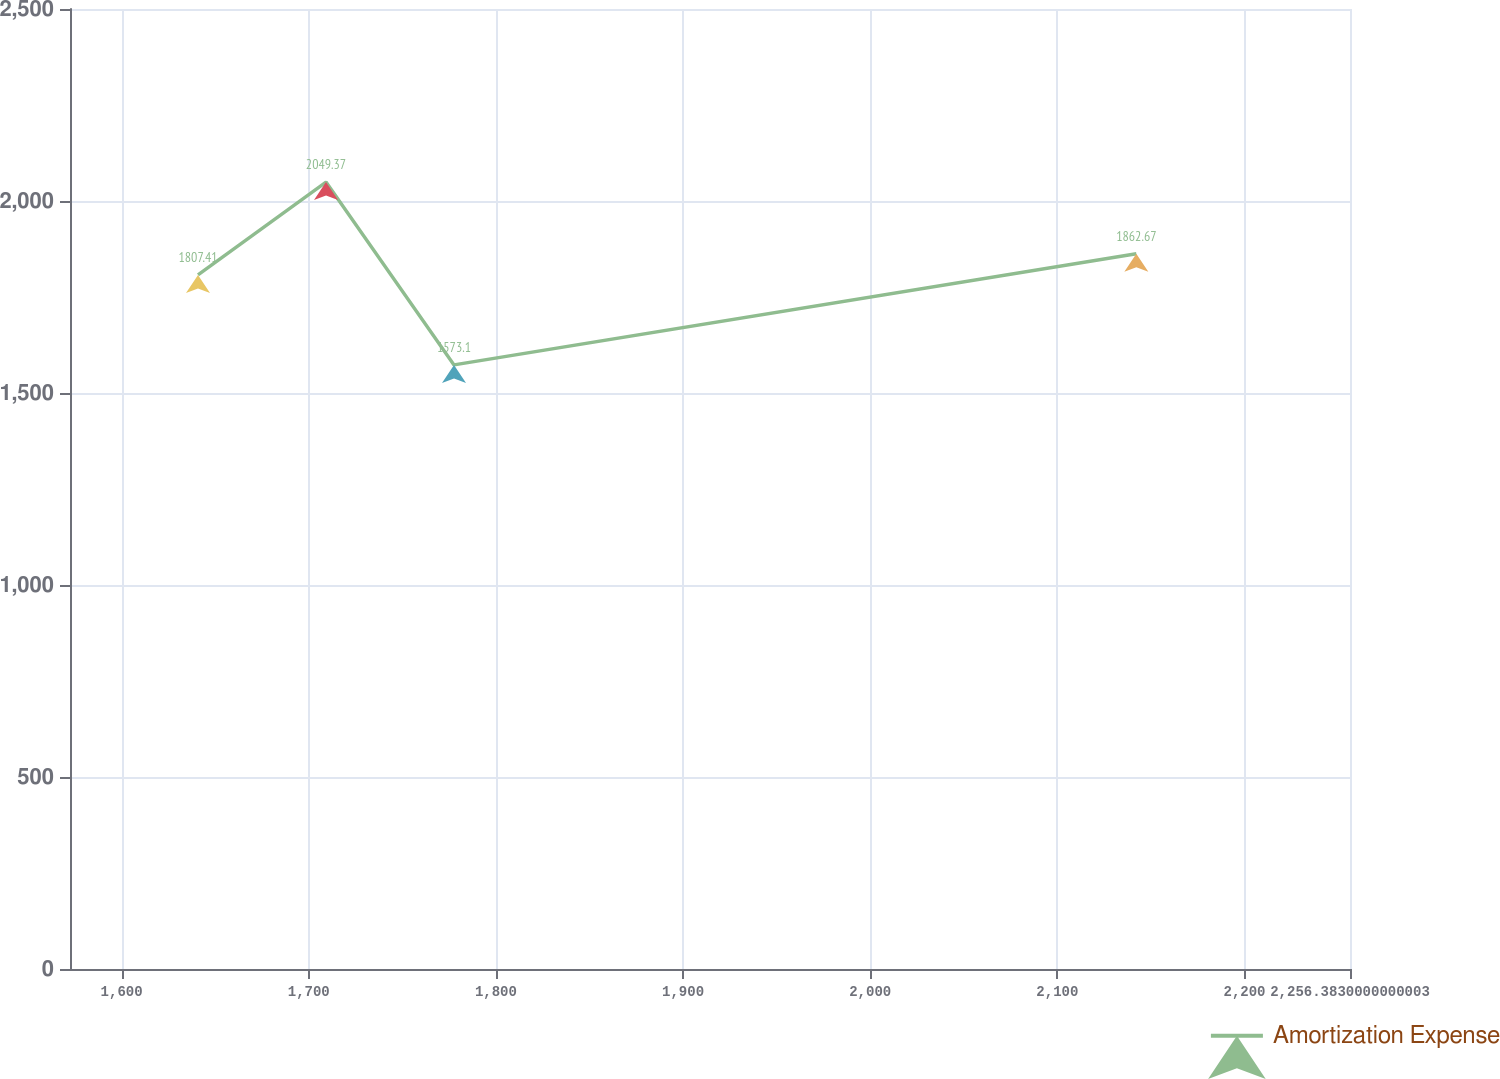Convert chart to OTSL. <chart><loc_0><loc_0><loc_500><loc_500><line_chart><ecel><fcel>Amortization Expense<nl><fcel>1640.81<fcel>1807.41<nl><fcel>1709.21<fcel>2049.37<nl><fcel>1777.61<fcel>1573.1<nl><fcel>2142.21<fcel>1862.67<nl><fcel>2324.78<fcel>1942.84<nl></chart> 